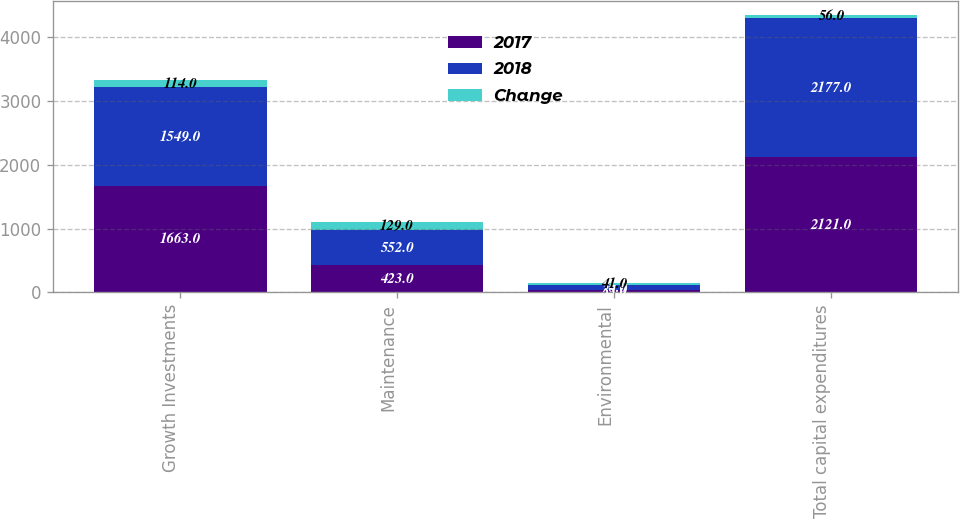Convert chart to OTSL. <chart><loc_0><loc_0><loc_500><loc_500><stacked_bar_chart><ecel><fcel>Growth Investments<fcel>Maintenance<fcel>Environmental<fcel>Total capital expenditures<nl><fcel>2017<fcel>1663<fcel>423<fcel>35<fcel>2121<nl><fcel>2018<fcel>1549<fcel>552<fcel>76<fcel>2177<nl><fcel>Change<fcel>114<fcel>129<fcel>41<fcel>56<nl></chart> 